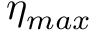<formula> <loc_0><loc_0><loc_500><loc_500>\eta _ { \max }</formula> 